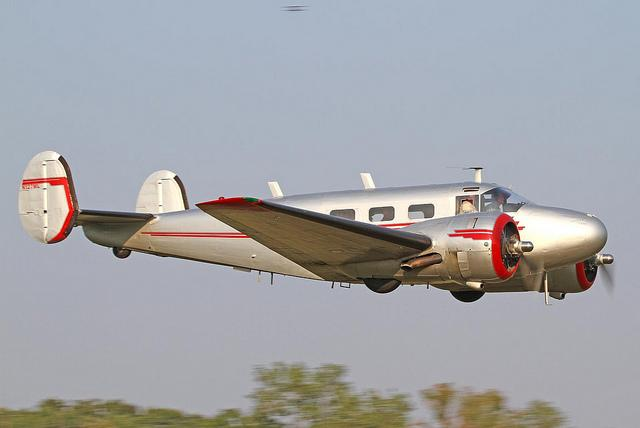What is seen in the sky?

Choices:
A) kite
B) airplane
C) bird
D) helicopter airplane 